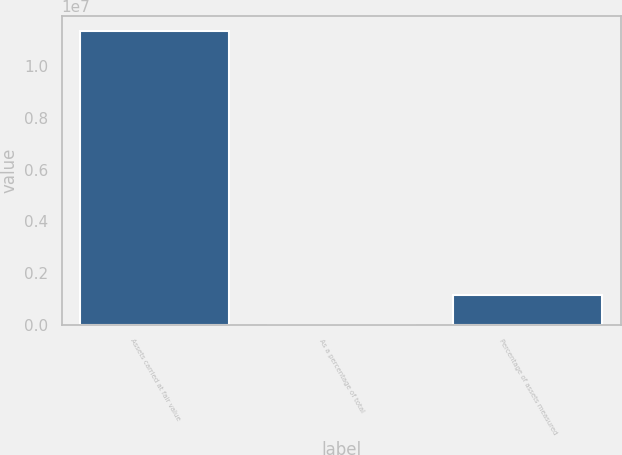Convert chart. <chart><loc_0><loc_0><loc_500><loc_500><bar_chart><fcel>Assets carried at fair value<fcel>As a percentage of total<fcel>Percentage of assets measured<nl><fcel>1.13721e+07<fcel>56.9<fcel>1.13726e+06<nl></chart> 